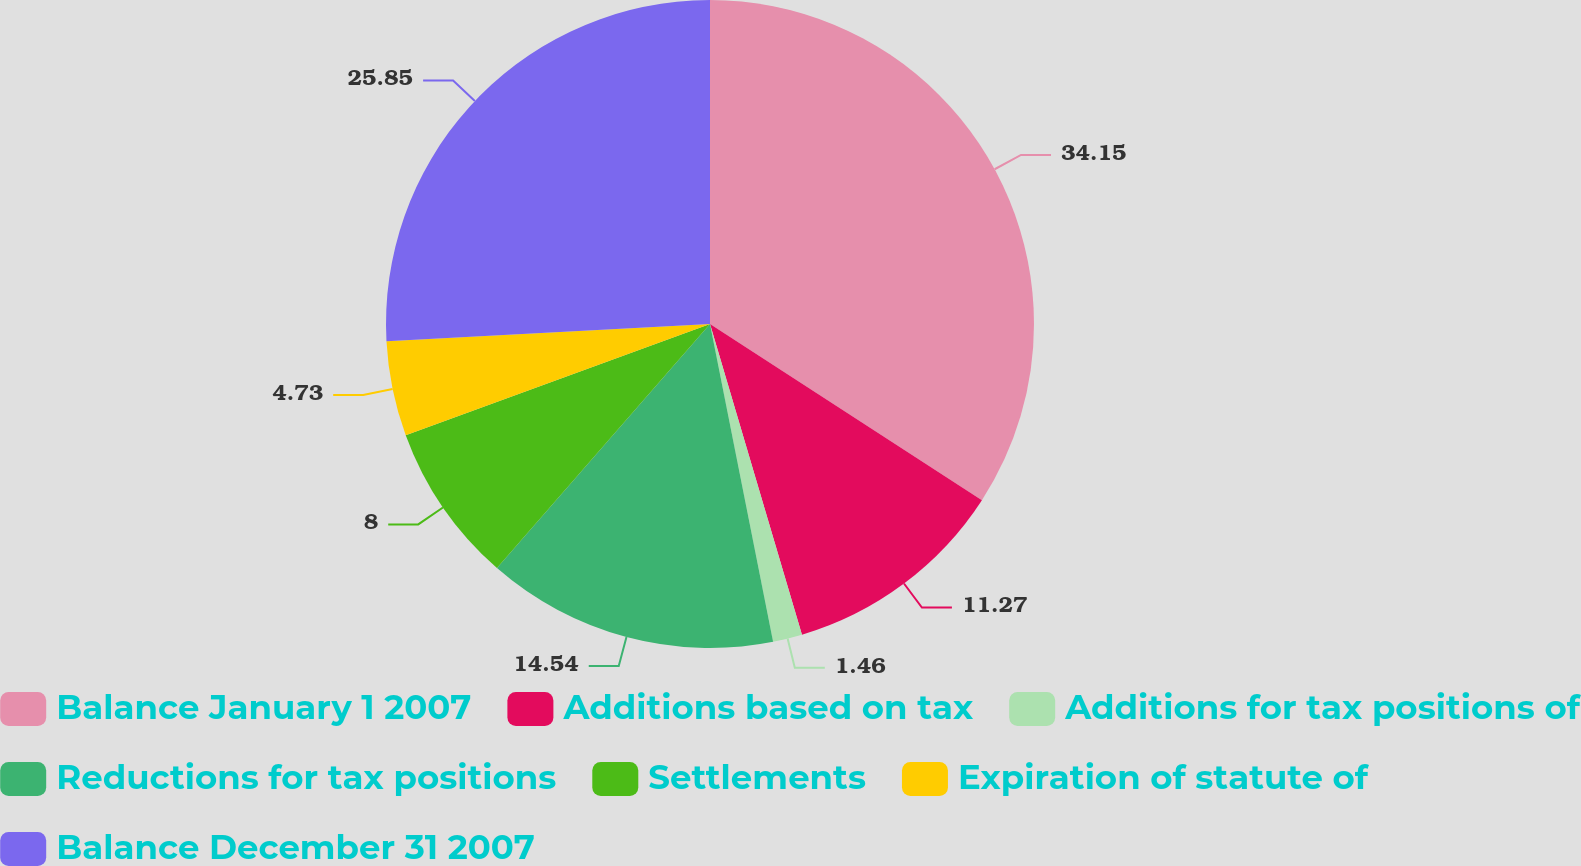Convert chart to OTSL. <chart><loc_0><loc_0><loc_500><loc_500><pie_chart><fcel>Balance January 1 2007<fcel>Additions based on tax<fcel>Additions for tax positions of<fcel>Reductions for tax positions<fcel>Settlements<fcel>Expiration of statute of<fcel>Balance December 31 2007<nl><fcel>34.15%<fcel>11.27%<fcel>1.46%<fcel>14.54%<fcel>8.0%<fcel>4.73%<fcel>25.85%<nl></chart> 